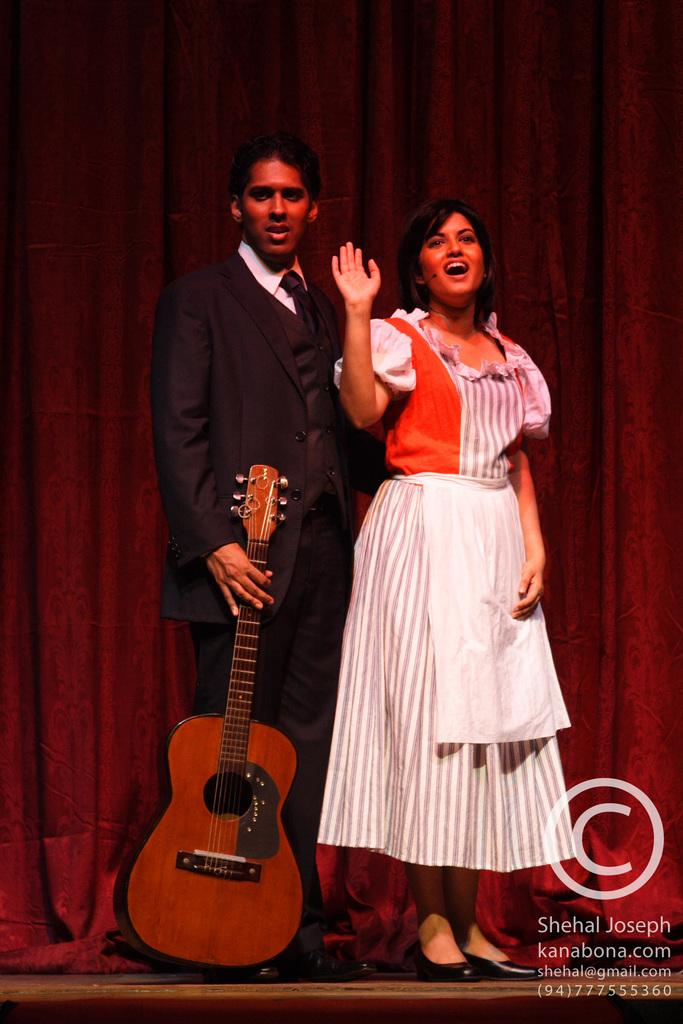How many people are in the image? There is a man and a woman in the image. What is the man holding in the image? The man is holding a guitar. What can be seen in the background of the image? There is a red curtain in the background of the image. What type of apparatus is being used by the woman to adjust the guitar in the image? There is no apparatus or adjustment being made to the guitar in the image, and the woman is not interacting with the guitar. 